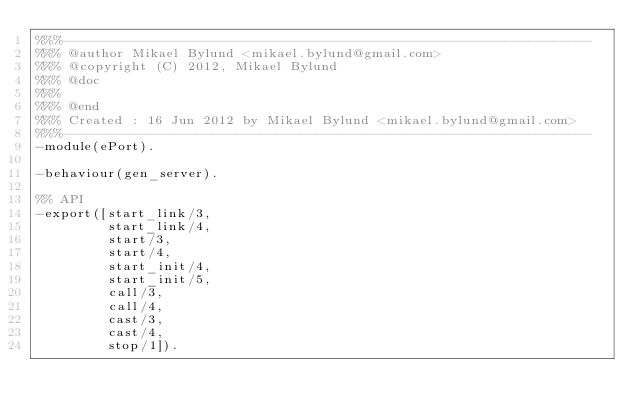<code> <loc_0><loc_0><loc_500><loc_500><_Erlang_>%%%-------------------------------------------------------------------
%%% @author Mikael Bylund <mikael.bylund@gmail.com>
%%% @copyright (C) 2012, Mikael Bylund
%%% @doc
%%%
%%% @end
%%% Created : 16 Jun 2012 by Mikael Bylund <mikael.bylund@gmail.com>
%%%-------------------------------------------------------------------
-module(ePort).

-behaviour(gen_server).

%% API
-export([start_link/3,
         start_link/4,
         start/3,
         start/4,
         start_init/4,
         start_init/5,
         call/3,
         call/4,
         cast/3,
         cast/4,
         stop/1]).
</code> 